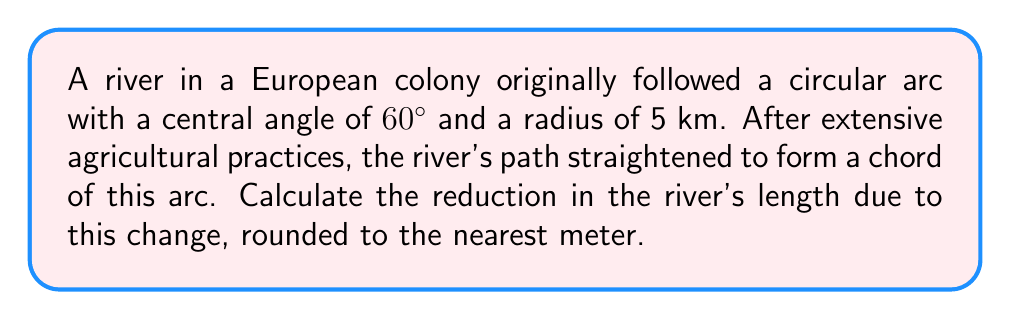Solve this math problem. To solve this problem, we'll follow these steps:

1) First, calculate the original length of the river (arc length):
   Arc length = $\frac{\theta}{360°} \cdot 2\pi r$
   where $\theta$ is the central angle in degrees and $r$ is the radius.
   
   $$\text{Arc length} = \frac{60°}{360°} \cdot 2\pi \cdot 5 \text{ km} = \frac{\pi}{3} \cdot 5 \text{ km} = \frac{5\pi}{3} \text{ km}$$

2) Next, calculate the length of the chord (new river path):
   Chord length = $2r \sin(\frac{\theta}{2})$
   
   $$\text{Chord length} = 2 \cdot 5 \cdot \sin(30°) = 10 \cdot \frac{1}{2} = 5 \text{ km}$$

3) Calculate the difference between the arc length and chord length:
   
   $$\text{Difference} = \frac{5\pi}{3} - 5 \text{ km} = \frac{5\pi - 15}{3} \text{ km}$$

4) Convert the result to meters and round to the nearest meter:
   
   $$\frac{5\pi - 15}{3} \cdot 1000 \approx 237.7 \text{ m} \approx 238 \text{ m}$$
Answer: 238 m 